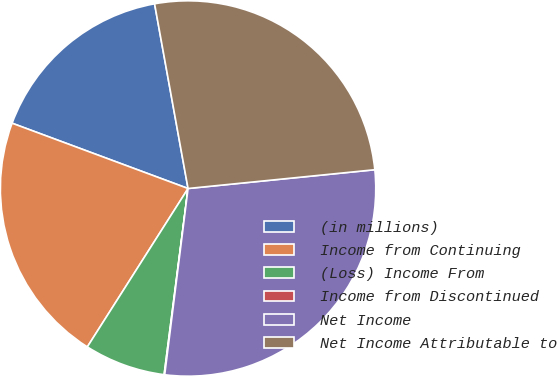<chart> <loc_0><loc_0><loc_500><loc_500><pie_chart><fcel>(in millions)<fcel>Income from Continuing<fcel>(Loss) Income From<fcel>Income from Discontinued<fcel>Net Income<fcel>Net Income Attributable to<nl><fcel>16.49%<fcel>21.64%<fcel>6.98%<fcel>0.05%<fcel>28.58%<fcel>26.26%<nl></chart> 